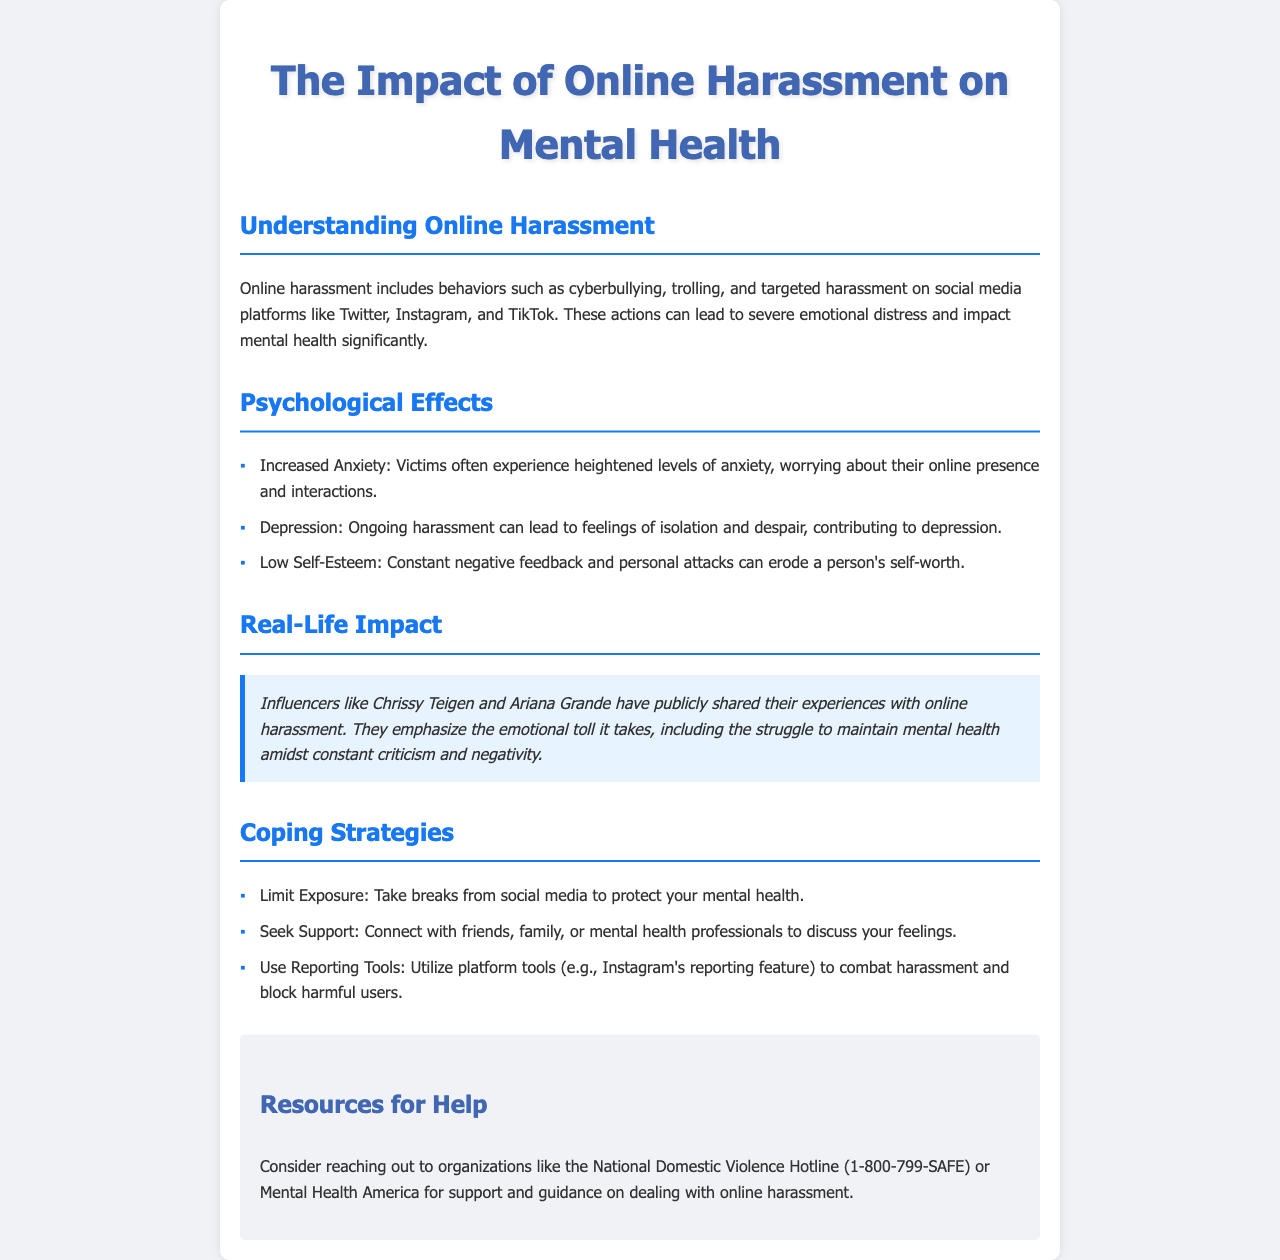What is online harassment? Online harassment includes behaviors such as cyberbullying, trolling, and targeted harassment on social media platforms.
Answer: Cyberbullying, trolling, targeted harassment What are two psychological effects of online harassment? The document lists various psychological effects, two of which include increased anxiety and depression.
Answer: Increased anxiety, depression Who are two influencers mentioned in relation to online harassment? The brochure mentions Chrissy Teigen and Ariana Grande sharing their experiences with online harassment.
Answer: Chrissy Teigen, Ariana Grande What is one coping strategy suggested in the brochure? The document provides several coping strategies, one of which is to limit exposure to social media.
Answer: Limit exposure What is the contact number for the National Domestic Violence Hotline? The brochure lists the hotline's number for those seeking help regarding online harassment.
Answer: 1-800-799-SAFE 